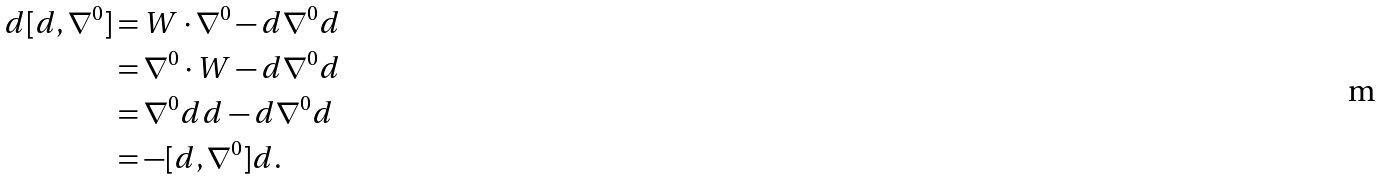<formula> <loc_0><loc_0><loc_500><loc_500>d [ d , \nabla ^ { 0 } ] & = W \cdot \nabla ^ { 0 } - d \nabla ^ { 0 } d \\ & = \nabla ^ { 0 } \cdot W - d \nabla ^ { 0 } d \\ & = \nabla ^ { 0 } d d - d \nabla ^ { 0 } d \\ & = - [ d , \nabla ^ { 0 } ] d .</formula> 